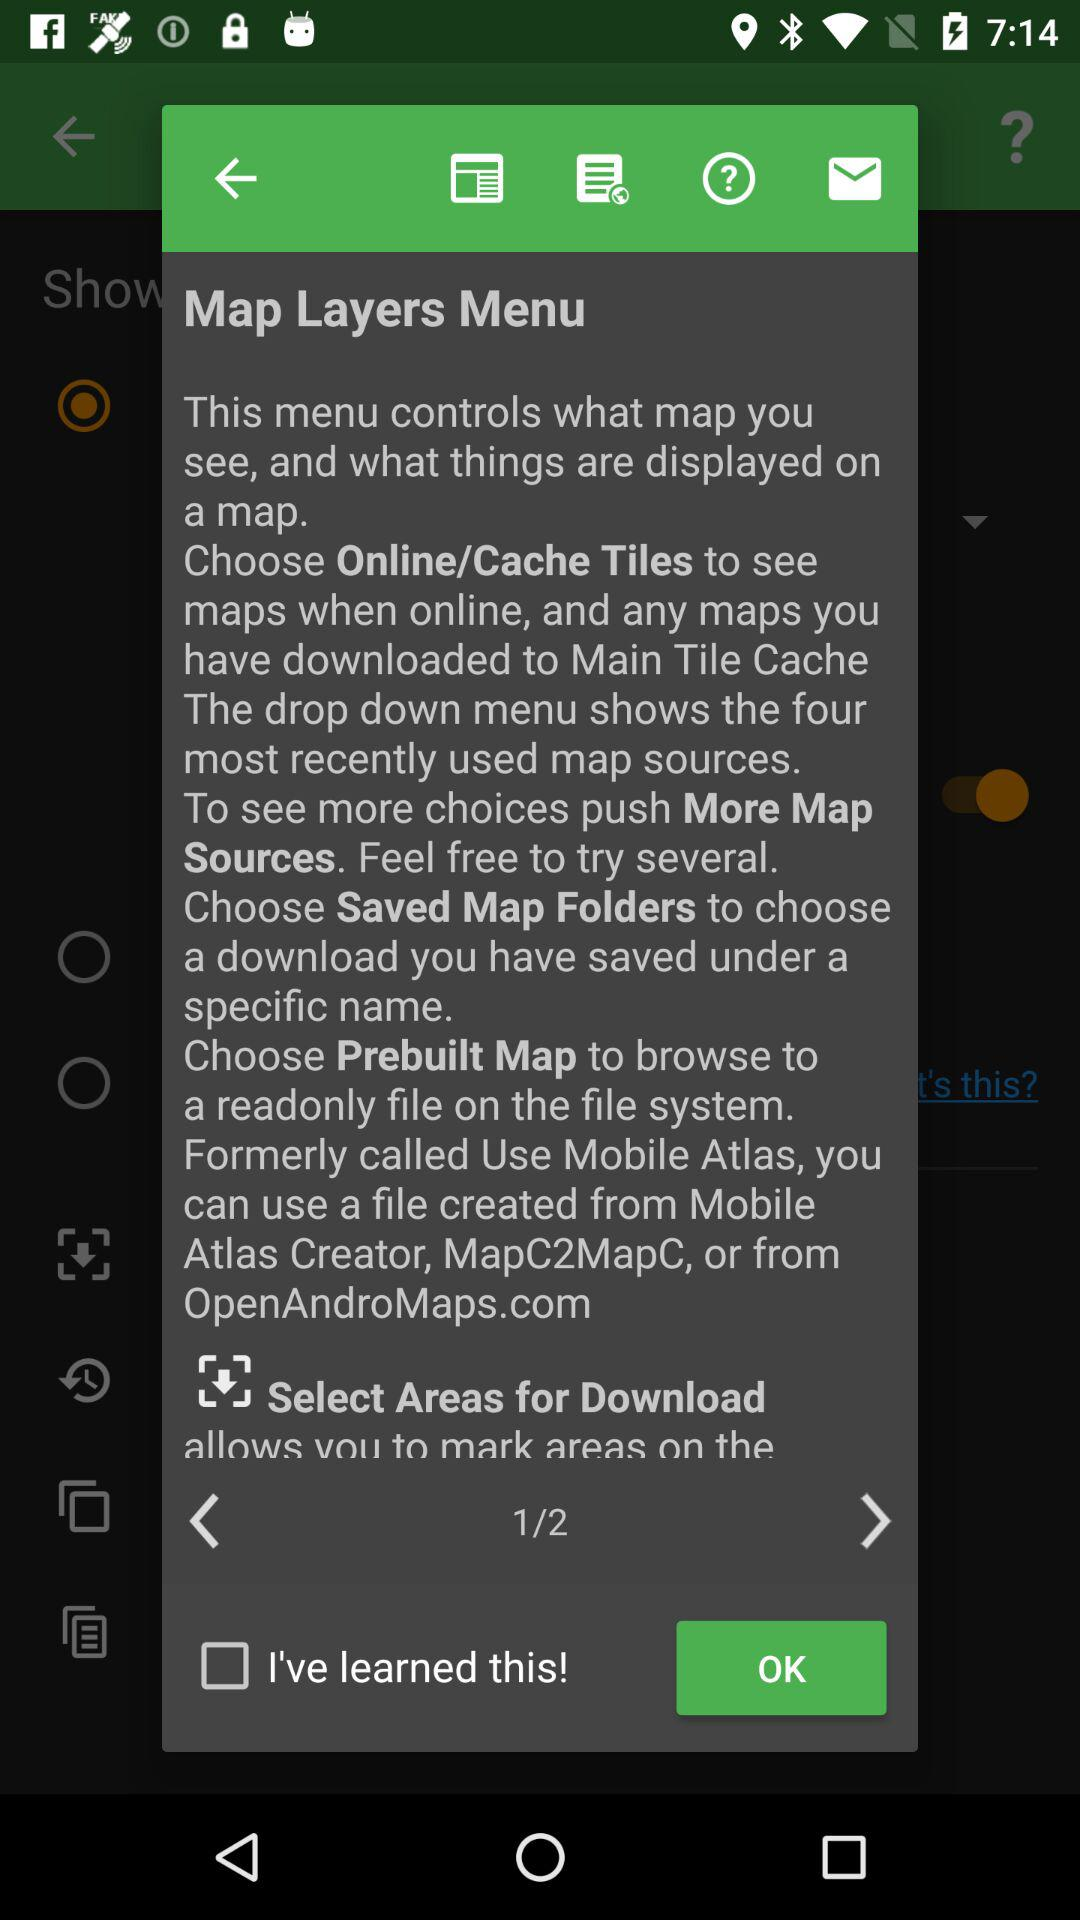What is the status of "I've learned this!"? The status of "I've learned this!" is "off". 